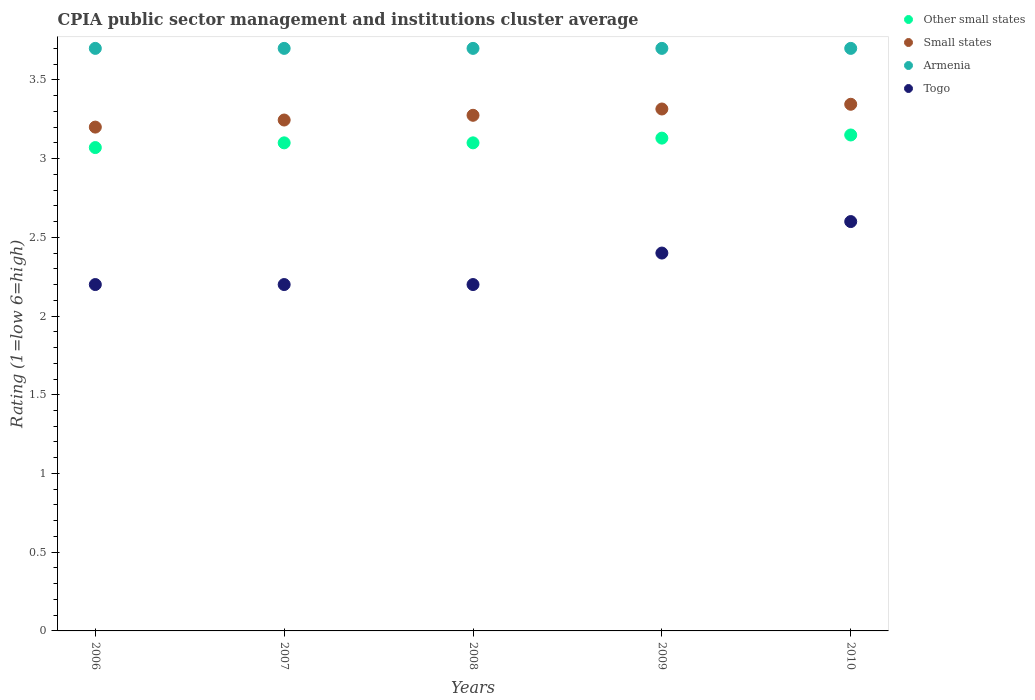What is the CPIA rating in Other small states in 2010?
Give a very brief answer. 3.15. Across all years, what is the maximum CPIA rating in Small states?
Your answer should be compact. 3.35. Across all years, what is the minimum CPIA rating in Other small states?
Provide a short and direct response. 3.07. In which year was the CPIA rating in Togo maximum?
Give a very brief answer. 2010. What is the total CPIA rating in Other small states in the graph?
Offer a very short reply. 15.55. What is the difference between the CPIA rating in Togo in 2008 and that in 2009?
Provide a short and direct response. -0.2. What is the difference between the CPIA rating in Small states in 2009 and the CPIA rating in Togo in 2010?
Your response must be concise. 0.71. What is the average CPIA rating in Togo per year?
Your answer should be compact. 2.32. In the year 2010, what is the difference between the CPIA rating in Togo and CPIA rating in Armenia?
Keep it short and to the point. -1.1. In how many years, is the CPIA rating in Small states greater than 1?
Offer a very short reply. 5. What is the ratio of the CPIA rating in Other small states in 2007 to that in 2008?
Offer a terse response. 1. Is the CPIA rating in Small states in 2006 less than that in 2008?
Give a very brief answer. Yes. What is the difference between the highest and the second highest CPIA rating in Armenia?
Make the answer very short. 0. What is the difference between the highest and the lowest CPIA rating in Small states?
Ensure brevity in your answer.  0.15. Is it the case that in every year, the sum of the CPIA rating in Armenia and CPIA rating in Small states  is greater than the sum of CPIA rating in Other small states and CPIA rating in Togo?
Keep it short and to the point. No. Does the CPIA rating in Small states monotonically increase over the years?
Provide a succinct answer. Yes. Is the CPIA rating in Togo strictly less than the CPIA rating in Armenia over the years?
Keep it short and to the point. Yes. How many years are there in the graph?
Your answer should be very brief. 5. How are the legend labels stacked?
Offer a terse response. Vertical. What is the title of the graph?
Ensure brevity in your answer.  CPIA public sector management and institutions cluster average. Does "High income: nonOECD" appear as one of the legend labels in the graph?
Offer a very short reply. No. What is the label or title of the X-axis?
Provide a short and direct response. Years. What is the label or title of the Y-axis?
Your response must be concise. Rating (1=low 6=high). What is the Rating (1=low 6=high) of Other small states in 2006?
Your response must be concise. 3.07. What is the Rating (1=low 6=high) in Armenia in 2006?
Provide a short and direct response. 3.7. What is the Rating (1=low 6=high) in Togo in 2006?
Offer a terse response. 2.2. What is the Rating (1=low 6=high) in Other small states in 2007?
Ensure brevity in your answer.  3.1. What is the Rating (1=low 6=high) in Small states in 2007?
Make the answer very short. 3.25. What is the Rating (1=low 6=high) in Small states in 2008?
Make the answer very short. 3.27. What is the Rating (1=low 6=high) of Armenia in 2008?
Your answer should be very brief. 3.7. What is the Rating (1=low 6=high) in Togo in 2008?
Your response must be concise. 2.2. What is the Rating (1=low 6=high) of Other small states in 2009?
Provide a succinct answer. 3.13. What is the Rating (1=low 6=high) in Small states in 2009?
Provide a succinct answer. 3.31. What is the Rating (1=low 6=high) in Armenia in 2009?
Your response must be concise. 3.7. What is the Rating (1=low 6=high) in Other small states in 2010?
Your response must be concise. 3.15. What is the Rating (1=low 6=high) in Small states in 2010?
Ensure brevity in your answer.  3.35. What is the Rating (1=low 6=high) in Armenia in 2010?
Your response must be concise. 3.7. What is the Rating (1=low 6=high) in Togo in 2010?
Provide a short and direct response. 2.6. Across all years, what is the maximum Rating (1=low 6=high) of Other small states?
Keep it short and to the point. 3.15. Across all years, what is the maximum Rating (1=low 6=high) in Small states?
Offer a very short reply. 3.35. Across all years, what is the maximum Rating (1=low 6=high) in Armenia?
Your answer should be compact. 3.7. Across all years, what is the maximum Rating (1=low 6=high) of Togo?
Make the answer very short. 2.6. Across all years, what is the minimum Rating (1=low 6=high) in Other small states?
Ensure brevity in your answer.  3.07. Across all years, what is the minimum Rating (1=low 6=high) in Small states?
Offer a terse response. 3.2. Across all years, what is the minimum Rating (1=low 6=high) of Armenia?
Keep it short and to the point. 3.7. Across all years, what is the minimum Rating (1=low 6=high) in Togo?
Your response must be concise. 2.2. What is the total Rating (1=low 6=high) of Other small states in the graph?
Provide a succinct answer. 15.55. What is the total Rating (1=low 6=high) of Small states in the graph?
Keep it short and to the point. 16.38. What is the difference between the Rating (1=low 6=high) in Other small states in 2006 and that in 2007?
Provide a succinct answer. -0.03. What is the difference between the Rating (1=low 6=high) in Small states in 2006 and that in 2007?
Keep it short and to the point. -0.04. What is the difference between the Rating (1=low 6=high) of Armenia in 2006 and that in 2007?
Your answer should be compact. 0. What is the difference between the Rating (1=low 6=high) in Other small states in 2006 and that in 2008?
Offer a terse response. -0.03. What is the difference between the Rating (1=low 6=high) in Small states in 2006 and that in 2008?
Your response must be concise. -0.07. What is the difference between the Rating (1=low 6=high) of Armenia in 2006 and that in 2008?
Make the answer very short. 0. What is the difference between the Rating (1=low 6=high) of Other small states in 2006 and that in 2009?
Ensure brevity in your answer.  -0.06. What is the difference between the Rating (1=low 6=high) of Small states in 2006 and that in 2009?
Offer a very short reply. -0.12. What is the difference between the Rating (1=low 6=high) in Other small states in 2006 and that in 2010?
Provide a short and direct response. -0.08. What is the difference between the Rating (1=low 6=high) of Small states in 2006 and that in 2010?
Your response must be concise. -0.14. What is the difference between the Rating (1=low 6=high) of Togo in 2006 and that in 2010?
Keep it short and to the point. -0.4. What is the difference between the Rating (1=low 6=high) in Small states in 2007 and that in 2008?
Your response must be concise. -0.03. What is the difference between the Rating (1=low 6=high) in Armenia in 2007 and that in 2008?
Provide a succinct answer. 0. What is the difference between the Rating (1=low 6=high) in Other small states in 2007 and that in 2009?
Your answer should be very brief. -0.03. What is the difference between the Rating (1=low 6=high) in Small states in 2007 and that in 2009?
Give a very brief answer. -0.07. What is the difference between the Rating (1=low 6=high) of Other small states in 2007 and that in 2010?
Provide a succinct answer. -0.05. What is the difference between the Rating (1=low 6=high) of Small states in 2007 and that in 2010?
Ensure brevity in your answer.  -0.1. What is the difference between the Rating (1=low 6=high) of Armenia in 2007 and that in 2010?
Make the answer very short. 0. What is the difference between the Rating (1=low 6=high) in Other small states in 2008 and that in 2009?
Your answer should be compact. -0.03. What is the difference between the Rating (1=low 6=high) of Small states in 2008 and that in 2009?
Give a very brief answer. -0.04. What is the difference between the Rating (1=low 6=high) in Armenia in 2008 and that in 2009?
Make the answer very short. 0. What is the difference between the Rating (1=low 6=high) of Togo in 2008 and that in 2009?
Keep it short and to the point. -0.2. What is the difference between the Rating (1=low 6=high) in Other small states in 2008 and that in 2010?
Make the answer very short. -0.05. What is the difference between the Rating (1=low 6=high) of Small states in 2008 and that in 2010?
Your answer should be very brief. -0.07. What is the difference between the Rating (1=low 6=high) in Armenia in 2008 and that in 2010?
Your response must be concise. 0. What is the difference between the Rating (1=low 6=high) in Togo in 2008 and that in 2010?
Ensure brevity in your answer.  -0.4. What is the difference between the Rating (1=low 6=high) in Other small states in 2009 and that in 2010?
Ensure brevity in your answer.  -0.02. What is the difference between the Rating (1=low 6=high) in Small states in 2009 and that in 2010?
Your answer should be compact. -0.03. What is the difference between the Rating (1=low 6=high) in Armenia in 2009 and that in 2010?
Offer a terse response. 0. What is the difference between the Rating (1=low 6=high) of Togo in 2009 and that in 2010?
Your answer should be compact. -0.2. What is the difference between the Rating (1=low 6=high) of Other small states in 2006 and the Rating (1=low 6=high) of Small states in 2007?
Provide a succinct answer. -0.17. What is the difference between the Rating (1=low 6=high) of Other small states in 2006 and the Rating (1=low 6=high) of Armenia in 2007?
Your answer should be very brief. -0.63. What is the difference between the Rating (1=low 6=high) of Other small states in 2006 and the Rating (1=low 6=high) of Togo in 2007?
Provide a succinct answer. 0.87. What is the difference between the Rating (1=low 6=high) of Small states in 2006 and the Rating (1=low 6=high) of Togo in 2007?
Offer a terse response. 1. What is the difference between the Rating (1=low 6=high) of Other small states in 2006 and the Rating (1=low 6=high) of Small states in 2008?
Keep it short and to the point. -0.2. What is the difference between the Rating (1=low 6=high) of Other small states in 2006 and the Rating (1=low 6=high) of Armenia in 2008?
Your response must be concise. -0.63. What is the difference between the Rating (1=low 6=high) of Other small states in 2006 and the Rating (1=low 6=high) of Togo in 2008?
Offer a terse response. 0.87. What is the difference between the Rating (1=low 6=high) of Small states in 2006 and the Rating (1=low 6=high) of Togo in 2008?
Make the answer very short. 1. What is the difference between the Rating (1=low 6=high) in Other small states in 2006 and the Rating (1=low 6=high) in Small states in 2009?
Make the answer very short. -0.24. What is the difference between the Rating (1=low 6=high) in Other small states in 2006 and the Rating (1=low 6=high) in Armenia in 2009?
Ensure brevity in your answer.  -0.63. What is the difference between the Rating (1=low 6=high) in Other small states in 2006 and the Rating (1=low 6=high) in Togo in 2009?
Offer a terse response. 0.67. What is the difference between the Rating (1=low 6=high) of Small states in 2006 and the Rating (1=low 6=high) of Armenia in 2009?
Provide a short and direct response. -0.5. What is the difference between the Rating (1=low 6=high) of Small states in 2006 and the Rating (1=low 6=high) of Togo in 2009?
Make the answer very short. 0.8. What is the difference between the Rating (1=low 6=high) of Other small states in 2006 and the Rating (1=low 6=high) of Small states in 2010?
Your answer should be very brief. -0.28. What is the difference between the Rating (1=low 6=high) in Other small states in 2006 and the Rating (1=low 6=high) in Armenia in 2010?
Provide a succinct answer. -0.63. What is the difference between the Rating (1=low 6=high) in Other small states in 2006 and the Rating (1=low 6=high) in Togo in 2010?
Your answer should be compact. 0.47. What is the difference between the Rating (1=low 6=high) in Small states in 2006 and the Rating (1=low 6=high) in Armenia in 2010?
Your answer should be very brief. -0.5. What is the difference between the Rating (1=low 6=high) of Small states in 2006 and the Rating (1=low 6=high) of Togo in 2010?
Your response must be concise. 0.6. What is the difference between the Rating (1=low 6=high) of Armenia in 2006 and the Rating (1=low 6=high) of Togo in 2010?
Provide a short and direct response. 1.1. What is the difference between the Rating (1=low 6=high) in Other small states in 2007 and the Rating (1=low 6=high) in Small states in 2008?
Give a very brief answer. -0.17. What is the difference between the Rating (1=low 6=high) in Small states in 2007 and the Rating (1=low 6=high) in Armenia in 2008?
Give a very brief answer. -0.46. What is the difference between the Rating (1=low 6=high) in Small states in 2007 and the Rating (1=low 6=high) in Togo in 2008?
Keep it short and to the point. 1.04. What is the difference between the Rating (1=low 6=high) in Other small states in 2007 and the Rating (1=low 6=high) in Small states in 2009?
Make the answer very short. -0.21. What is the difference between the Rating (1=low 6=high) of Other small states in 2007 and the Rating (1=low 6=high) of Armenia in 2009?
Offer a very short reply. -0.6. What is the difference between the Rating (1=low 6=high) of Small states in 2007 and the Rating (1=low 6=high) of Armenia in 2009?
Provide a short and direct response. -0.46. What is the difference between the Rating (1=low 6=high) in Small states in 2007 and the Rating (1=low 6=high) in Togo in 2009?
Offer a terse response. 0.84. What is the difference between the Rating (1=low 6=high) of Other small states in 2007 and the Rating (1=low 6=high) of Small states in 2010?
Offer a terse response. -0.24. What is the difference between the Rating (1=low 6=high) in Small states in 2007 and the Rating (1=low 6=high) in Armenia in 2010?
Give a very brief answer. -0.46. What is the difference between the Rating (1=low 6=high) in Small states in 2007 and the Rating (1=low 6=high) in Togo in 2010?
Your response must be concise. 0.65. What is the difference between the Rating (1=low 6=high) in Other small states in 2008 and the Rating (1=low 6=high) in Small states in 2009?
Give a very brief answer. -0.21. What is the difference between the Rating (1=low 6=high) of Other small states in 2008 and the Rating (1=low 6=high) of Togo in 2009?
Make the answer very short. 0.7. What is the difference between the Rating (1=low 6=high) in Small states in 2008 and the Rating (1=low 6=high) in Armenia in 2009?
Offer a very short reply. -0.42. What is the difference between the Rating (1=low 6=high) in Armenia in 2008 and the Rating (1=low 6=high) in Togo in 2009?
Provide a succinct answer. 1.3. What is the difference between the Rating (1=low 6=high) in Other small states in 2008 and the Rating (1=low 6=high) in Small states in 2010?
Your answer should be compact. -0.24. What is the difference between the Rating (1=low 6=high) in Other small states in 2008 and the Rating (1=low 6=high) in Armenia in 2010?
Keep it short and to the point. -0.6. What is the difference between the Rating (1=low 6=high) in Other small states in 2008 and the Rating (1=low 6=high) in Togo in 2010?
Keep it short and to the point. 0.5. What is the difference between the Rating (1=low 6=high) in Small states in 2008 and the Rating (1=low 6=high) in Armenia in 2010?
Offer a terse response. -0.42. What is the difference between the Rating (1=low 6=high) of Small states in 2008 and the Rating (1=low 6=high) of Togo in 2010?
Give a very brief answer. 0.68. What is the difference between the Rating (1=low 6=high) of Armenia in 2008 and the Rating (1=low 6=high) of Togo in 2010?
Offer a very short reply. 1.1. What is the difference between the Rating (1=low 6=high) in Other small states in 2009 and the Rating (1=low 6=high) in Small states in 2010?
Keep it short and to the point. -0.21. What is the difference between the Rating (1=low 6=high) of Other small states in 2009 and the Rating (1=low 6=high) of Armenia in 2010?
Your answer should be compact. -0.57. What is the difference between the Rating (1=low 6=high) in Other small states in 2009 and the Rating (1=low 6=high) in Togo in 2010?
Provide a short and direct response. 0.53. What is the difference between the Rating (1=low 6=high) in Small states in 2009 and the Rating (1=low 6=high) in Armenia in 2010?
Give a very brief answer. -0.39. What is the difference between the Rating (1=low 6=high) of Small states in 2009 and the Rating (1=low 6=high) of Togo in 2010?
Offer a very short reply. 0.71. What is the average Rating (1=low 6=high) in Other small states per year?
Offer a terse response. 3.11. What is the average Rating (1=low 6=high) of Small states per year?
Make the answer very short. 3.28. What is the average Rating (1=low 6=high) in Armenia per year?
Your answer should be very brief. 3.7. What is the average Rating (1=low 6=high) in Togo per year?
Keep it short and to the point. 2.32. In the year 2006, what is the difference between the Rating (1=low 6=high) in Other small states and Rating (1=low 6=high) in Small states?
Provide a succinct answer. -0.13. In the year 2006, what is the difference between the Rating (1=low 6=high) in Other small states and Rating (1=low 6=high) in Armenia?
Your response must be concise. -0.63. In the year 2006, what is the difference between the Rating (1=low 6=high) in Other small states and Rating (1=low 6=high) in Togo?
Make the answer very short. 0.87. In the year 2006, what is the difference between the Rating (1=low 6=high) in Small states and Rating (1=low 6=high) in Armenia?
Keep it short and to the point. -0.5. In the year 2006, what is the difference between the Rating (1=low 6=high) of Small states and Rating (1=low 6=high) of Togo?
Give a very brief answer. 1. In the year 2006, what is the difference between the Rating (1=low 6=high) in Armenia and Rating (1=low 6=high) in Togo?
Your answer should be compact. 1.5. In the year 2007, what is the difference between the Rating (1=low 6=high) in Other small states and Rating (1=low 6=high) in Small states?
Give a very brief answer. -0.14. In the year 2007, what is the difference between the Rating (1=low 6=high) in Other small states and Rating (1=low 6=high) in Armenia?
Give a very brief answer. -0.6. In the year 2007, what is the difference between the Rating (1=low 6=high) in Other small states and Rating (1=low 6=high) in Togo?
Provide a short and direct response. 0.9. In the year 2007, what is the difference between the Rating (1=low 6=high) of Small states and Rating (1=low 6=high) of Armenia?
Keep it short and to the point. -0.46. In the year 2007, what is the difference between the Rating (1=low 6=high) in Small states and Rating (1=low 6=high) in Togo?
Your answer should be compact. 1.04. In the year 2008, what is the difference between the Rating (1=low 6=high) of Other small states and Rating (1=low 6=high) of Small states?
Your response must be concise. -0.17. In the year 2008, what is the difference between the Rating (1=low 6=high) of Other small states and Rating (1=low 6=high) of Togo?
Provide a short and direct response. 0.9. In the year 2008, what is the difference between the Rating (1=low 6=high) of Small states and Rating (1=low 6=high) of Armenia?
Your answer should be compact. -0.42. In the year 2008, what is the difference between the Rating (1=low 6=high) of Small states and Rating (1=low 6=high) of Togo?
Make the answer very short. 1.07. In the year 2009, what is the difference between the Rating (1=low 6=high) of Other small states and Rating (1=low 6=high) of Small states?
Give a very brief answer. -0.18. In the year 2009, what is the difference between the Rating (1=low 6=high) of Other small states and Rating (1=low 6=high) of Armenia?
Provide a short and direct response. -0.57. In the year 2009, what is the difference between the Rating (1=low 6=high) in Other small states and Rating (1=low 6=high) in Togo?
Make the answer very short. 0.73. In the year 2009, what is the difference between the Rating (1=low 6=high) in Small states and Rating (1=low 6=high) in Armenia?
Give a very brief answer. -0.39. In the year 2009, what is the difference between the Rating (1=low 6=high) of Small states and Rating (1=low 6=high) of Togo?
Make the answer very short. 0.92. In the year 2010, what is the difference between the Rating (1=low 6=high) of Other small states and Rating (1=low 6=high) of Small states?
Keep it short and to the point. -0.2. In the year 2010, what is the difference between the Rating (1=low 6=high) of Other small states and Rating (1=low 6=high) of Armenia?
Make the answer very short. -0.55. In the year 2010, what is the difference between the Rating (1=low 6=high) of Other small states and Rating (1=low 6=high) of Togo?
Make the answer very short. 0.55. In the year 2010, what is the difference between the Rating (1=low 6=high) of Small states and Rating (1=low 6=high) of Armenia?
Keep it short and to the point. -0.35. In the year 2010, what is the difference between the Rating (1=low 6=high) of Small states and Rating (1=low 6=high) of Togo?
Make the answer very short. 0.74. What is the ratio of the Rating (1=low 6=high) in Other small states in 2006 to that in 2007?
Provide a succinct answer. 0.99. What is the ratio of the Rating (1=low 6=high) in Small states in 2006 to that in 2007?
Your answer should be compact. 0.99. What is the ratio of the Rating (1=low 6=high) in Other small states in 2006 to that in 2008?
Your answer should be very brief. 0.99. What is the ratio of the Rating (1=low 6=high) of Small states in 2006 to that in 2008?
Offer a terse response. 0.98. What is the ratio of the Rating (1=low 6=high) of Armenia in 2006 to that in 2008?
Offer a very short reply. 1. What is the ratio of the Rating (1=low 6=high) of Togo in 2006 to that in 2008?
Your answer should be very brief. 1. What is the ratio of the Rating (1=low 6=high) of Other small states in 2006 to that in 2009?
Keep it short and to the point. 0.98. What is the ratio of the Rating (1=low 6=high) in Small states in 2006 to that in 2009?
Offer a terse response. 0.97. What is the ratio of the Rating (1=low 6=high) in Other small states in 2006 to that in 2010?
Offer a terse response. 0.97. What is the ratio of the Rating (1=low 6=high) of Small states in 2006 to that in 2010?
Your answer should be compact. 0.96. What is the ratio of the Rating (1=low 6=high) in Armenia in 2006 to that in 2010?
Ensure brevity in your answer.  1. What is the ratio of the Rating (1=low 6=high) in Togo in 2006 to that in 2010?
Your answer should be compact. 0.85. What is the ratio of the Rating (1=low 6=high) of Other small states in 2007 to that in 2009?
Make the answer very short. 0.99. What is the ratio of the Rating (1=low 6=high) in Small states in 2007 to that in 2009?
Ensure brevity in your answer.  0.98. What is the ratio of the Rating (1=low 6=high) in Togo in 2007 to that in 2009?
Make the answer very short. 0.92. What is the ratio of the Rating (1=low 6=high) in Other small states in 2007 to that in 2010?
Make the answer very short. 0.98. What is the ratio of the Rating (1=low 6=high) in Small states in 2007 to that in 2010?
Your answer should be very brief. 0.97. What is the ratio of the Rating (1=low 6=high) of Togo in 2007 to that in 2010?
Give a very brief answer. 0.85. What is the ratio of the Rating (1=low 6=high) of Small states in 2008 to that in 2009?
Provide a short and direct response. 0.99. What is the ratio of the Rating (1=low 6=high) of Armenia in 2008 to that in 2009?
Provide a short and direct response. 1. What is the ratio of the Rating (1=low 6=high) in Other small states in 2008 to that in 2010?
Offer a very short reply. 0.98. What is the ratio of the Rating (1=low 6=high) of Small states in 2008 to that in 2010?
Provide a short and direct response. 0.98. What is the ratio of the Rating (1=low 6=high) of Togo in 2008 to that in 2010?
Give a very brief answer. 0.85. What is the ratio of the Rating (1=low 6=high) of Armenia in 2009 to that in 2010?
Provide a succinct answer. 1. What is the ratio of the Rating (1=low 6=high) in Togo in 2009 to that in 2010?
Your answer should be very brief. 0.92. What is the difference between the highest and the second highest Rating (1=low 6=high) of Other small states?
Give a very brief answer. 0.02. What is the difference between the highest and the second highest Rating (1=low 6=high) of Small states?
Your answer should be very brief. 0.03. What is the difference between the highest and the second highest Rating (1=low 6=high) of Armenia?
Give a very brief answer. 0. What is the difference between the highest and the lowest Rating (1=low 6=high) of Small states?
Offer a very short reply. 0.14. What is the difference between the highest and the lowest Rating (1=low 6=high) of Armenia?
Offer a very short reply. 0. What is the difference between the highest and the lowest Rating (1=low 6=high) in Togo?
Provide a succinct answer. 0.4. 